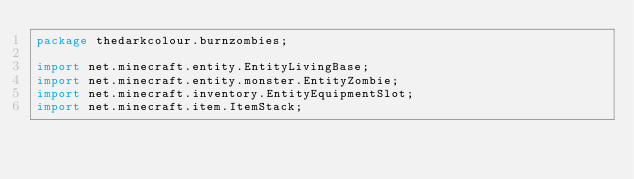Convert code to text. <code><loc_0><loc_0><loc_500><loc_500><_Java_>package thedarkcolour.burnzombies;

import net.minecraft.entity.EntityLivingBase;
import net.minecraft.entity.monster.EntityZombie;
import net.minecraft.inventory.EntityEquipmentSlot;
import net.minecraft.item.ItemStack;</code> 